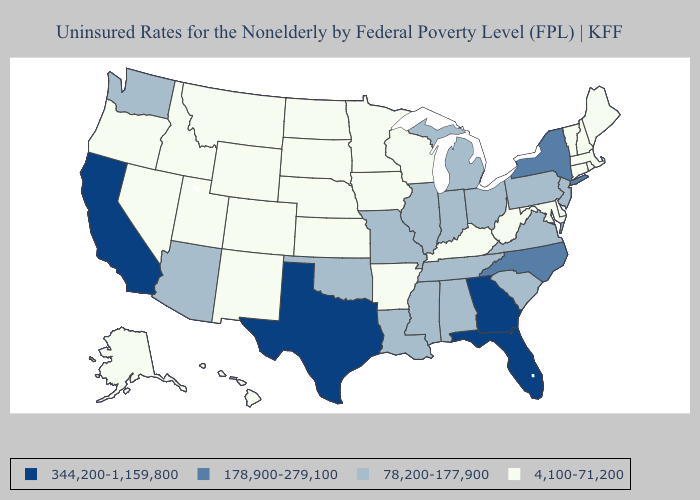Which states have the lowest value in the South?
Write a very short answer. Arkansas, Delaware, Kentucky, Maryland, West Virginia. What is the value of Washington?
Keep it brief. 78,200-177,900. Which states have the lowest value in the USA?
Concise answer only. Alaska, Arkansas, Colorado, Connecticut, Delaware, Hawaii, Idaho, Iowa, Kansas, Kentucky, Maine, Maryland, Massachusetts, Minnesota, Montana, Nebraska, Nevada, New Hampshire, New Mexico, North Dakota, Oregon, Rhode Island, South Dakota, Utah, Vermont, West Virginia, Wisconsin, Wyoming. Does Oklahoma have the lowest value in the South?
Short answer required. No. What is the value of Nebraska?
Be succinct. 4,100-71,200. What is the value of North Dakota?
Write a very short answer. 4,100-71,200. What is the highest value in states that border Georgia?
Answer briefly. 344,200-1,159,800. Name the states that have a value in the range 78,200-177,900?
Short answer required. Alabama, Arizona, Illinois, Indiana, Louisiana, Michigan, Mississippi, Missouri, New Jersey, Ohio, Oklahoma, Pennsylvania, South Carolina, Tennessee, Virginia, Washington. Which states have the highest value in the USA?
Give a very brief answer. California, Florida, Georgia, Texas. What is the highest value in the USA?
Keep it brief. 344,200-1,159,800. What is the value of Kentucky?
Write a very short answer. 4,100-71,200. How many symbols are there in the legend?
Give a very brief answer. 4. Does Pennsylvania have the lowest value in the USA?
Keep it brief. No. Is the legend a continuous bar?
Quick response, please. No. 